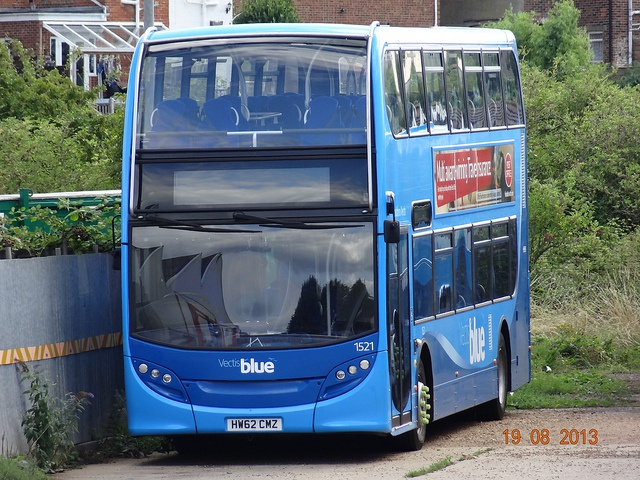Describe the objects in this image and their specific colors. I can see bus in brown, gray, black, and blue tones in this image. 